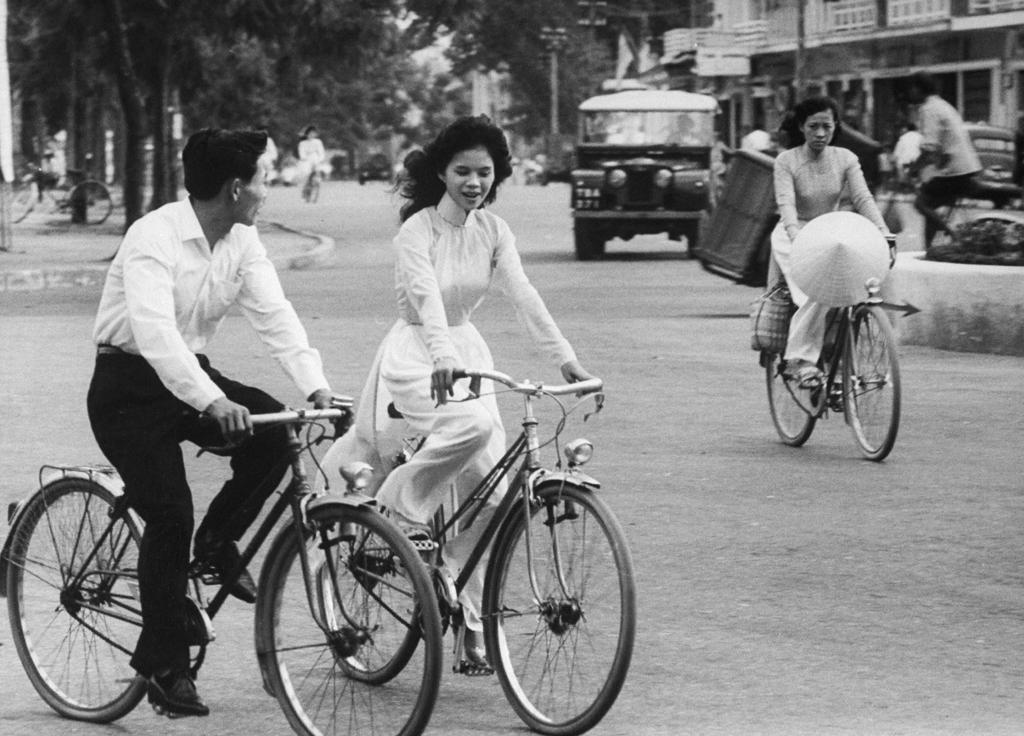What are the three people in the image doing? The three people are riding bicycles in the image. Where are the bicycles located? The bicycles are on a road in the image. What else can be seen on the road in the image? There is a car on the road in the image. What is visible on the right side of the image? There are buildings on the right side of the image. What can be seen in the background of the image? There are trees in the background of the image. What type of shoes are the people wearing while riding the bicycles in the image? There is no information about the shoes the people are wearing in the image. 